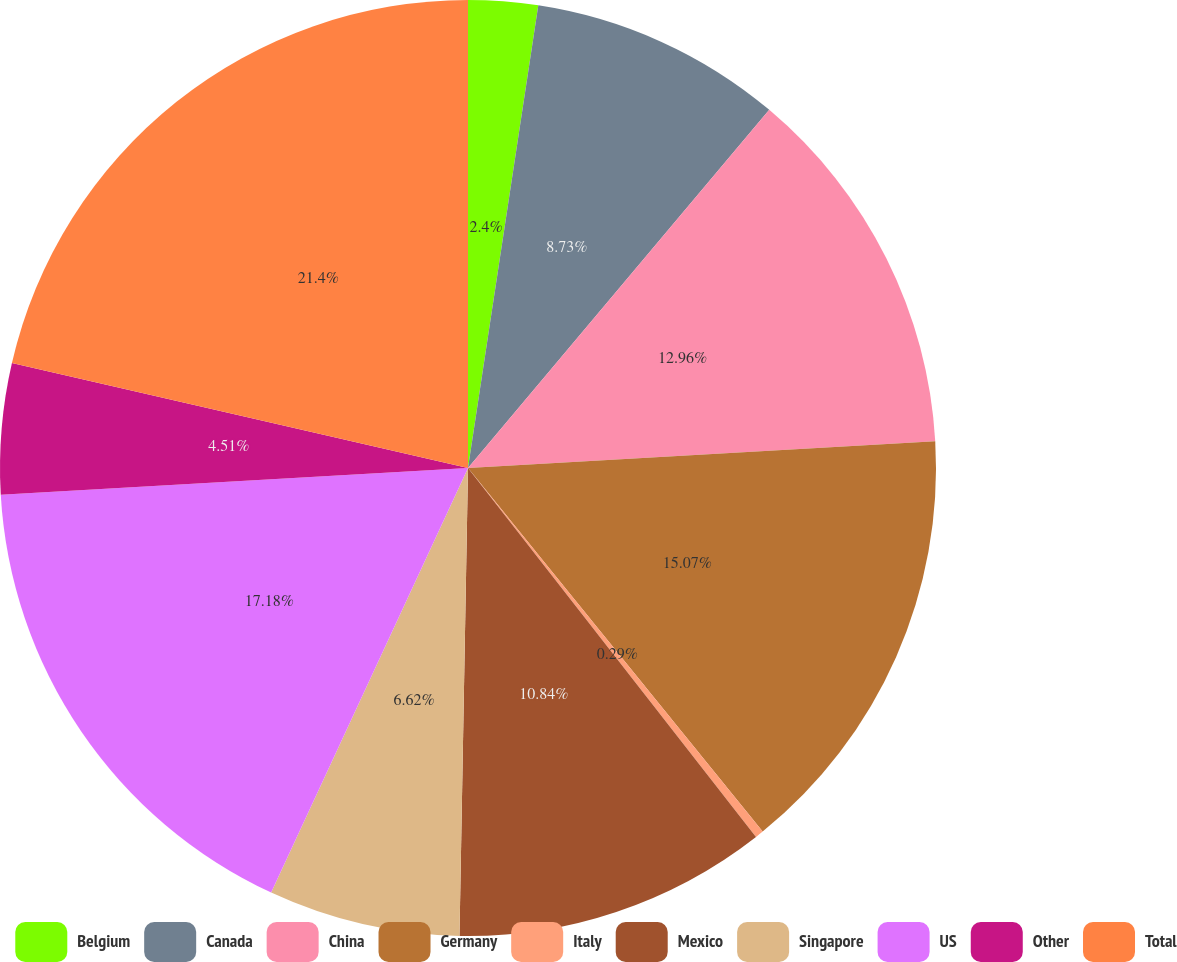<chart> <loc_0><loc_0><loc_500><loc_500><pie_chart><fcel>Belgium<fcel>Canada<fcel>China<fcel>Germany<fcel>Italy<fcel>Mexico<fcel>Singapore<fcel>US<fcel>Other<fcel>Total<nl><fcel>2.4%<fcel>8.73%<fcel>12.96%<fcel>15.07%<fcel>0.29%<fcel>10.84%<fcel>6.62%<fcel>17.18%<fcel>4.51%<fcel>21.4%<nl></chart> 